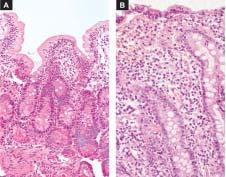there is shortening and blunting of the villi with reduction in whose height?
Answer the question using a single word or phrase. Their 